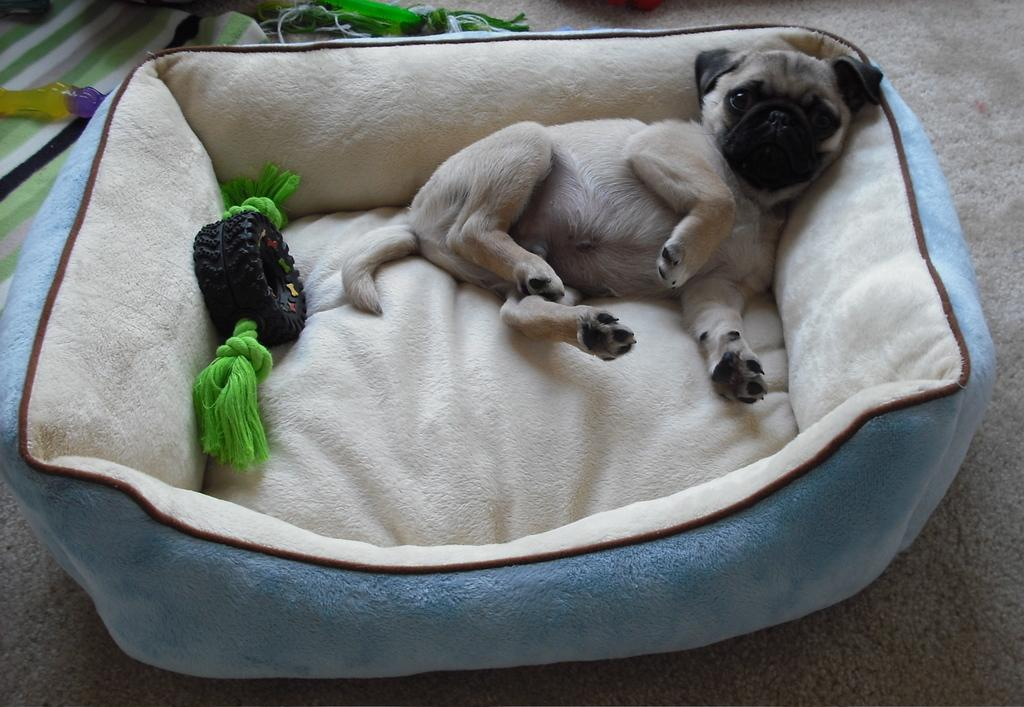What type of animal is in the image? There is a pug in the image. What else can be seen in the image besides the pug? There is a toy in the image. Where are the pug and toy located? The pug and toy are on a dog bed. How is the dog bed positioned in the image? The dog bed is placed on the floor. What type of material might be covering the dog bed? There is a cloth present in the image, which could be covering the dog bed. Can you tell me how many ladybugs are on the pug in the image? There are no ladybugs present in the image; it features a pug and a toy on a dog bed. 